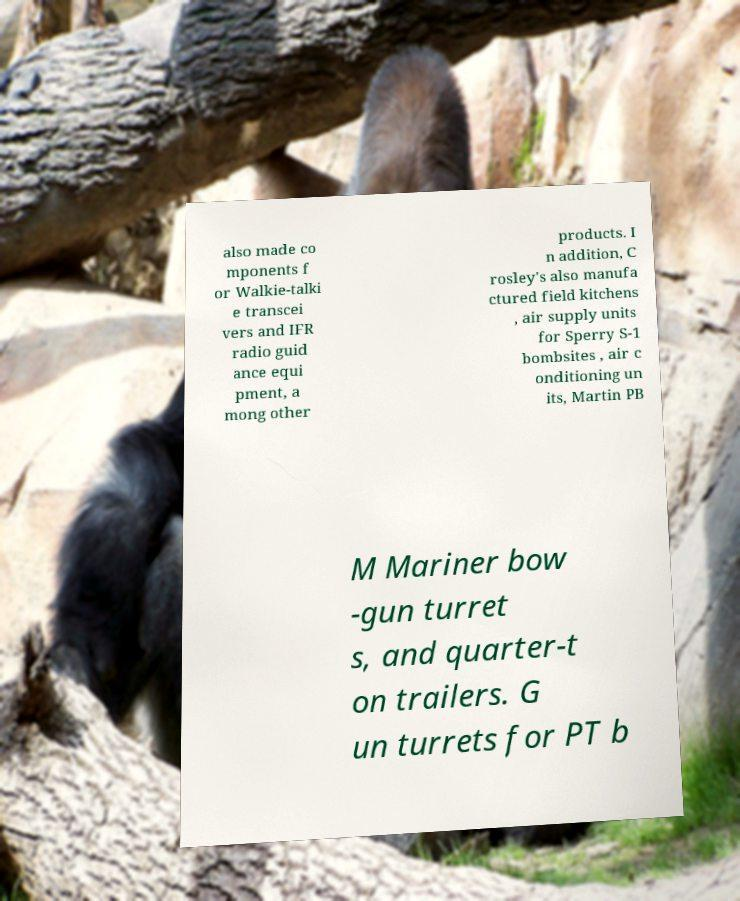For documentation purposes, I need the text within this image transcribed. Could you provide that? also made co mponents f or Walkie-talki e transcei vers and IFR radio guid ance equi pment, a mong other products. I n addition, C rosley's also manufa ctured field kitchens , air supply units for Sperry S-1 bombsites , air c onditioning un its, Martin PB M Mariner bow -gun turret s, and quarter-t on trailers. G un turrets for PT b 